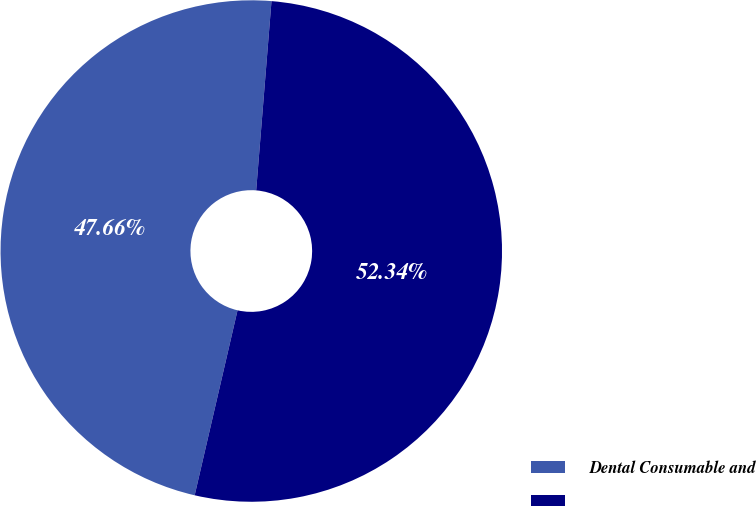Convert chart to OTSL. <chart><loc_0><loc_0><loc_500><loc_500><pie_chart><fcel>Dental Consumable and<fcel>Unnamed: 1<nl><fcel>47.66%<fcel>52.34%<nl></chart> 